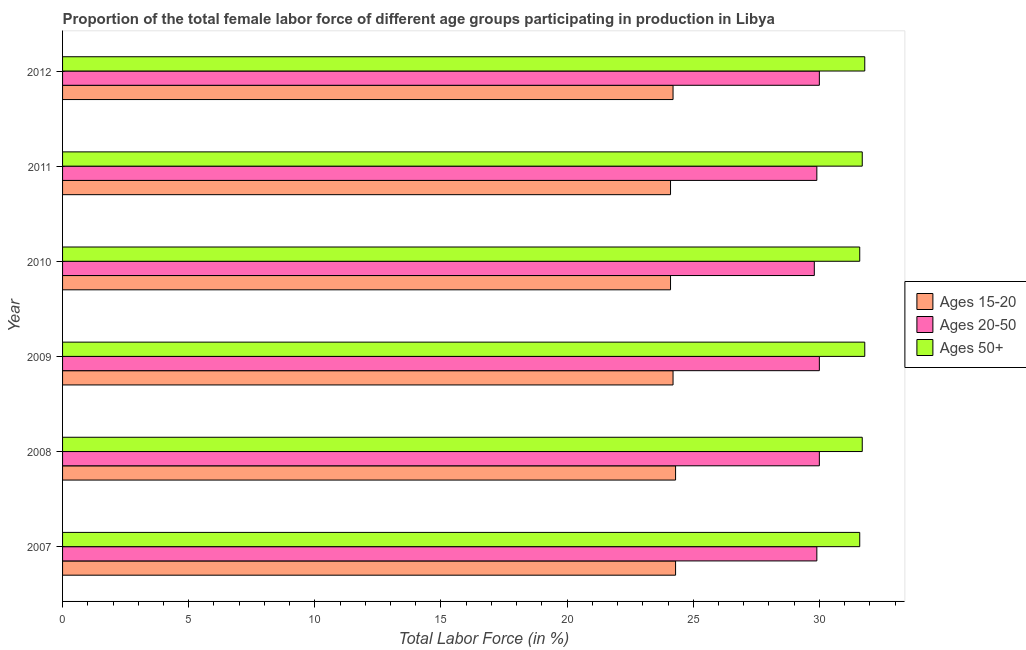How many different coloured bars are there?
Your answer should be very brief. 3. Are the number of bars on each tick of the Y-axis equal?
Provide a succinct answer. Yes. What is the label of the 2nd group of bars from the top?
Make the answer very short. 2011. What is the percentage of female labor force above age 50 in 2009?
Your answer should be compact. 31.8. Across all years, what is the maximum percentage of female labor force within the age group 20-50?
Offer a terse response. 30. Across all years, what is the minimum percentage of female labor force within the age group 15-20?
Give a very brief answer. 24.1. In which year was the percentage of female labor force within the age group 15-20 minimum?
Make the answer very short. 2010. What is the total percentage of female labor force above age 50 in the graph?
Ensure brevity in your answer.  190.2. What is the difference between the percentage of female labor force above age 50 in 2007 and that in 2011?
Your response must be concise. -0.1. What is the average percentage of female labor force within the age group 15-20 per year?
Provide a succinct answer. 24.2. What is the ratio of the percentage of female labor force within the age group 15-20 in 2007 to that in 2012?
Offer a very short reply. 1. Is the difference between the percentage of female labor force within the age group 20-50 in 2009 and 2011 greater than the difference between the percentage of female labor force above age 50 in 2009 and 2011?
Provide a short and direct response. Yes. What is the difference between the highest and the second highest percentage of female labor force above age 50?
Make the answer very short. 0. What is the difference between the highest and the lowest percentage of female labor force within the age group 15-20?
Offer a very short reply. 0.2. In how many years, is the percentage of female labor force above age 50 greater than the average percentage of female labor force above age 50 taken over all years?
Offer a terse response. 4. What does the 3rd bar from the top in 2012 represents?
Your answer should be compact. Ages 15-20. What does the 2nd bar from the bottom in 2012 represents?
Your answer should be compact. Ages 20-50. Is it the case that in every year, the sum of the percentage of female labor force within the age group 15-20 and percentage of female labor force within the age group 20-50 is greater than the percentage of female labor force above age 50?
Your response must be concise. Yes. How many bars are there?
Provide a short and direct response. 18. How many years are there in the graph?
Give a very brief answer. 6. What is the difference between two consecutive major ticks on the X-axis?
Ensure brevity in your answer.  5. Does the graph contain grids?
Your answer should be very brief. No. Where does the legend appear in the graph?
Your answer should be compact. Center right. How many legend labels are there?
Your response must be concise. 3. How are the legend labels stacked?
Ensure brevity in your answer.  Vertical. What is the title of the graph?
Provide a succinct answer. Proportion of the total female labor force of different age groups participating in production in Libya. Does "Taxes" appear as one of the legend labels in the graph?
Offer a terse response. No. What is the Total Labor Force (in %) in Ages 15-20 in 2007?
Offer a very short reply. 24.3. What is the Total Labor Force (in %) of Ages 20-50 in 2007?
Your answer should be very brief. 29.9. What is the Total Labor Force (in %) of Ages 50+ in 2007?
Offer a terse response. 31.6. What is the Total Labor Force (in %) in Ages 15-20 in 2008?
Offer a terse response. 24.3. What is the Total Labor Force (in %) in Ages 20-50 in 2008?
Provide a short and direct response. 30. What is the Total Labor Force (in %) in Ages 50+ in 2008?
Ensure brevity in your answer.  31.7. What is the Total Labor Force (in %) of Ages 15-20 in 2009?
Offer a very short reply. 24.2. What is the Total Labor Force (in %) in Ages 20-50 in 2009?
Provide a short and direct response. 30. What is the Total Labor Force (in %) in Ages 50+ in 2009?
Offer a very short reply. 31.8. What is the Total Labor Force (in %) of Ages 15-20 in 2010?
Your response must be concise. 24.1. What is the Total Labor Force (in %) of Ages 20-50 in 2010?
Make the answer very short. 29.8. What is the Total Labor Force (in %) of Ages 50+ in 2010?
Ensure brevity in your answer.  31.6. What is the Total Labor Force (in %) of Ages 15-20 in 2011?
Make the answer very short. 24.1. What is the Total Labor Force (in %) of Ages 20-50 in 2011?
Provide a succinct answer. 29.9. What is the Total Labor Force (in %) in Ages 50+ in 2011?
Make the answer very short. 31.7. What is the Total Labor Force (in %) in Ages 15-20 in 2012?
Provide a short and direct response. 24.2. What is the Total Labor Force (in %) of Ages 50+ in 2012?
Provide a short and direct response. 31.8. Across all years, what is the maximum Total Labor Force (in %) of Ages 15-20?
Keep it short and to the point. 24.3. Across all years, what is the maximum Total Labor Force (in %) of Ages 50+?
Give a very brief answer. 31.8. Across all years, what is the minimum Total Labor Force (in %) in Ages 15-20?
Provide a short and direct response. 24.1. Across all years, what is the minimum Total Labor Force (in %) in Ages 20-50?
Give a very brief answer. 29.8. Across all years, what is the minimum Total Labor Force (in %) in Ages 50+?
Your answer should be compact. 31.6. What is the total Total Labor Force (in %) in Ages 15-20 in the graph?
Your response must be concise. 145.2. What is the total Total Labor Force (in %) of Ages 20-50 in the graph?
Your response must be concise. 179.6. What is the total Total Labor Force (in %) of Ages 50+ in the graph?
Your answer should be very brief. 190.2. What is the difference between the Total Labor Force (in %) of Ages 15-20 in 2007 and that in 2008?
Ensure brevity in your answer.  0. What is the difference between the Total Labor Force (in %) in Ages 50+ in 2007 and that in 2008?
Provide a short and direct response. -0.1. What is the difference between the Total Labor Force (in %) in Ages 50+ in 2007 and that in 2009?
Your response must be concise. -0.2. What is the difference between the Total Labor Force (in %) in Ages 50+ in 2007 and that in 2010?
Provide a succinct answer. 0. What is the difference between the Total Labor Force (in %) of Ages 20-50 in 2007 and that in 2011?
Your response must be concise. 0. What is the difference between the Total Labor Force (in %) of Ages 50+ in 2007 and that in 2011?
Your response must be concise. -0.1. What is the difference between the Total Labor Force (in %) of Ages 15-20 in 2007 and that in 2012?
Ensure brevity in your answer.  0.1. What is the difference between the Total Labor Force (in %) in Ages 20-50 in 2007 and that in 2012?
Offer a terse response. -0.1. What is the difference between the Total Labor Force (in %) of Ages 50+ in 2007 and that in 2012?
Provide a succinct answer. -0.2. What is the difference between the Total Labor Force (in %) of Ages 20-50 in 2008 and that in 2009?
Make the answer very short. 0. What is the difference between the Total Labor Force (in %) in Ages 50+ in 2008 and that in 2009?
Your answer should be very brief. -0.1. What is the difference between the Total Labor Force (in %) in Ages 15-20 in 2008 and that in 2010?
Ensure brevity in your answer.  0.2. What is the difference between the Total Labor Force (in %) in Ages 15-20 in 2008 and that in 2011?
Provide a short and direct response. 0.2. What is the difference between the Total Labor Force (in %) in Ages 20-50 in 2008 and that in 2012?
Offer a very short reply. 0. What is the difference between the Total Labor Force (in %) in Ages 50+ in 2008 and that in 2012?
Provide a short and direct response. -0.1. What is the difference between the Total Labor Force (in %) of Ages 15-20 in 2009 and that in 2010?
Make the answer very short. 0.1. What is the difference between the Total Labor Force (in %) of Ages 15-20 in 2009 and that in 2011?
Your answer should be compact. 0.1. What is the difference between the Total Labor Force (in %) in Ages 20-50 in 2009 and that in 2011?
Keep it short and to the point. 0.1. What is the difference between the Total Labor Force (in %) of Ages 50+ in 2009 and that in 2011?
Your answer should be compact. 0.1. What is the difference between the Total Labor Force (in %) in Ages 15-20 in 2009 and that in 2012?
Your response must be concise. 0. What is the difference between the Total Labor Force (in %) in Ages 15-20 in 2010 and that in 2012?
Your response must be concise. -0.1. What is the difference between the Total Labor Force (in %) of Ages 20-50 in 2010 and that in 2012?
Offer a very short reply. -0.2. What is the difference between the Total Labor Force (in %) in Ages 20-50 in 2011 and that in 2012?
Your response must be concise. -0.1. What is the difference between the Total Labor Force (in %) in Ages 50+ in 2011 and that in 2012?
Make the answer very short. -0.1. What is the difference between the Total Labor Force (in %) in Ages 15-20 in 2007 and the Total Labor Force (in %) in Ages 20-50 in 2009?
Offer a very short reply. -5.7. What is the difference between the Total Labor Force (in %) of Ages 15-20 in 2007 and the Total Labor Force (in %) of Ages 50+ in 2009?
Offer a very short reply. -7.5. What is the difference between the Total Labor Force (in %) of Ages 20-50 in 2007 and the Total Labor Force (in %) of Ages 50+ in 2009?
Your answer should be compact. -1.9. What is the difference between the Total Labor Force (in %) of Ages 15-20 in 2007 and the Total Labor Force (in %) of Ages 50+ in 2010?
Your answer should be very brief. -7.3. What is the difference between the Total Labor Force (in %) in Ages 20-50 in 2007 and the Total Labor Force (in %) in Ages 50+ in 2010?
Ensure brevity in your answer.  -1.7. What is the difference between the Total Labor Force (in %) in Ages 15-20 in 2007 and the Total Labor Force (in %) in Ages 20-50 in 2011?
Keep it short and to the point. -5.6. What is the difference between the Total Labor Force (in %) in Ages 20-50 in 2007 and the Total Labor Force (in %) in Ages 50+ in 2011?
Offer a very short reply. -1.8. What is the difference between the Total Labor Force (in %) in Ages 15-20 in 2007 and the Total Labor Force (in %) in Ages 20-50 in 2012?
Offer a very short reply. -5.7. What is the difference between the Total Labor Force (in %) of Ages 15-20 in 2007 and the Total Labor Force (in %) of Ages 50+ in 2012?
Your answer should be very brief. -7.5. What is the difference between the Total Labor Force (in %) in Ages 20-50 in 2007 and the Total Labor Force (in %) in Ages 50+ in 2012?
Keep it short and to the point. -1.9. What is the difference between the Total Labor Force (in %) in Ages 15-20 in 2008 and the Total Labor Force (in %) in Ages 20-50 in 2010?
Provide a short and direct response. -5.5. What is the difference between the Total Labor Force (in %) of Ages 15-20 in 2008 and the Total Labor Force (in %) of Ages 50+ in 2010?
Offer a terse response. -7.3. What is the difference between the Total Labor Force (in %) of Ages 20-50 in 2008 and the Total Labor Force (in %) of Ages 50+ in 2010?
Your answer should be very brief. -1.6. What is the difference between the Total Labor Force (in %) of Ages 15-20 in 2008 and the Total Labor Force (in %) of Ages 20-50 in 2011?
Your answer should be very brief. -5.6. What is the difference between the Total Labor Force (in %) in Ages 15-20 in 2008 and the Total Labor Force (in %) in Ages 50+ in 2011?
Provide a short and direct response. -7.4. What is the difference between the Total Labor Force (in %) of Ages 20-50 in 2008 and the Total Labor Force (in %) of Ages 50+ in 2012?
Ensure brevity in your answer.  -1.8. What is the difference between the Total Labor Force (in %) in Ages 15-20 in 2009 and the Total Labor Force (in %) in Ages 20-50 in 2010?
Offer a very short reply. -5.6. What is the difference between the Total Labor Force (in %) of Ages 15-20 in 2009 and the Total Labor Force (in %) of Ages 50+ in 2010?
Give a very brief answer. -7.4. What is the difference between the Total Labor Force (in %) of Ages 20-50 in 2009 and the Total Labor Force (in %) of Ages 50+ in 2010?
Offer a terse response. -1.6. What is the difference between the Total Labor Force (in %) of Ages 15-20 in 2009 and the Total Labor Force (in %) of Ages 20-50 in 2011?
Your answer should be compact. -5.7. What is the difference between the Total Labor Force (in %) in Ages 15-20 in 2009 and the Total Labor Force (in %) in Ages 50+ in 2011?
Your response must be concise. -7.5. What is the difference between the Total Labor Force (in %) of Ages 15-20 in 2009 and the Total Labor Force (in %) of Ages 50+ in 2012?
Your response must be concise. -7.6. What is the difference between the Total Labor Force (in %) in Ages 15-20 in 2010 and the Total Labor Force (in %) in Ages 50+ in 2011?
Provide a short and direct response. -7.6. What is the difference between the Total Labor Force (in %) in Ages 20-50 in 2010 and the Total Labor Force (in %) in Ages 50+ in 2011?
Give a very brief answer. -1.9. What is the difference between the Total Labor Force (in %) in Ages 20-50 in 2010 and the Total Labor Force (in %) in Ages 50+ in 2012?
Your response must be concise. -2. What is the difference between the Total Labor Force (in %) in Ages 15-20 in 2011 and the Total Labor Force (in %) in Ages 50+ in 2012?
Your answer should be compact. -7.7. What is the difference between the Total Labor Force (in %) of Ages 20-50 in 2011 and the Total Labor Force (in %) of Ages 50+ in 2012?
Ensure brevity in your answer.  -1.9. What is the average Total Labor Force (in %) in Ages 15-20 per year?
Offer a terse response. 24.2. What is the average Total Labor Force (in %) of Ages 20-50 per year?
Your answer should be very brief. 29.93. What is the average Total Labor Force (in %) of Ages 50+ per year?
Ensure brevity in your answer.  31.7. In the year 2007, what is the difference between the Total Labor Force (in %) of Ages 15-20 and Total Labor Force (in %) of Ages 20-50?
Make the answer very short. -5.6. In the year 2007, what is the difference between the Total Labor Force (in %) of Ages 15-20 and Total Labor Force (in %) of Ages 50+?
Make the answer very short. -7.3. In the year 2007, what is the difference between the Total Labor Force (in %) in Ages 20-50 and Total Labor Force (in %) in Ages 50+?
Offer a very short reply. -1.7. In the year 2008, what is the difference between the Total Labor Force (in %) of Ages 15-20 and Total Labor Force (in %) of Ages 20-50?
Provide a short and direct response. -5.7. In the year 2009, what is the difference between the Total Labor Force (in %) of Ages 15-20 and Total Labor Force (in %) of Ages 20-50?
Provide a short and direct response. -5.8. In the year 2009, what is the difference between the Total Labor Force (in %) in Ages 15-20 and Total Labor Force (in %) in Ages 50+?
Give a very brief answer. -7.6. In the year 2010, what is the difference between the Total Labor Force (in %) in Ages 15-20 and Total Labor Force (in %) in Ages 50+?
Make the answer very short. -7.5. In the year 2010, what is the difference between the Total Labor Force (in %) in Ages 20-50 and Total Labor Force (in %) in Ages 50+?
Your response must be concise. -1.8. In the year 2011, what is the difference between the Total Labor Force (in %) in Ages 15-20 and Total Labor Force (in %) in Ages 20-50?
Your answer should be very brief. -5.8. In the year 2012, what is the difference between the Total Labor Force (in %) of Ages 15-20 and Total Labor Force (in %) of Ages 20-50?
Make the answer very short. -5.8. In the year 2012, what is the difference between the Total Labor Force (in %) of Ages 20-50 and Total Labor Force (in %) of Ages 50+?
Offer a terse response. -1.8. What is the ratio of the Total Labor Force (in %) of Ages 20-50 in 2007 to that in 2008?
Your answer should be very brief. 1. What is the ratio of the Total Labor Force (in %) of Ages 50+ in 2007 to that in 2008?
Provide a short and direct response. 1. What is the ratio of the Total Labor Force (in %) in Ages 15-20 in 2007 to that in 2009?
Ensure brevity in your answer.  1. What is the ratio of the Total Labor Force (in %) of Ages 20-50 in 2007 to that in 2009?
Your response must be concise. 1. What is the ratio of the Total Labor Force (in %) of Ages 50+ in 2007 to that in 2009?
Ensure brevity in your answer.  0.99. What is the ratio of the Total Labor Force (in %) in Ages 15-20 in 2007 to that in 2010?
Your response must be concise. 1.01. What is the ratio of the Total Labor Force (in %) in Ages 15-20 in 2007 to that in 2011?
Offer a very short reply. 1.01. What is the ratio of the Total Labor Force (in %) in Ages 20-50 in 2007 to that in 2011?
Provide a succinct answer. 1. What is the ratio of the Total Labor Force (in %) of Ages 20-50 in 2007 to that in 2012?
Offer a very short reply. 1. What is the ratio of the Total Labor Force (in %) of Ages 50+ in 2007 to that in 2012?
Make the answer very short. 0.99. What is the ratio of the Total Labor Force (in %) of Ages 15-20 in 2008 to that in 2009?
Provide a succinct answer. 1. What is the ratio of the Total Labor Force (in %) in Ages 50+ in 2008 to that in 2009?
Your answer should be compact. 1. What is the ratio of the Total Labor Force (in %) of Ages 15-20 in 2008 to that in 2010?
Your response must be concise. 1.01. What is the ratio of the Total Labor Force (in %) in Ages 15-20 in 2008 to that in 2011?
Give a very brief answer. 1.01. What is the ratio of the Total Labor Force (in %) of Ages 50+ in 2008 to that in 2011?
Provide a succinct answer. 1. What is the ratio of the Total Labor Force (in %) of Ages 15-20 in 2008 to that in 2012?
Give a very brief answer. 1. What is the ratio of the Total Labor Force (in %) in Ages 20-50 in 2008 to that in 2012?
Ensure brevity in your answer.  1. What is the ratio of the Total Labor Force (in %) in Ages 20-50 in 2009 to that in 2010?
Offer a terse response. 1.01. What is the ratio of the Total Labor Force (in %) in Ages 50+ in 2009 to that in 2011?
Provide a succinct answer. 1. What is the ratio of the Total Labor Force (in %) in Ages 15-20 in 2009 to that in 2012?
Offer a very short reply. 1. What is the ratio of the Total Labor Force (in %) of Ages 50+ in 2009 to that in 2012?
Keep it short and to the point. 1. What is the ratio of the Total Labor Force (in %) of Ages 15-20 in 2010 to that in 2011?
Keep it short and to the point. 1. What is the ratio of the Total Labor Force (in %) in Ages 15-20 in 2010 to that in 2012?
Provide a succinct answer. 1. What is the ratio of the Total Labor Force (in %) of Ages 50+ in 2010 to that in 2012?
Your response must be concise. 0.99. What is the ratio of the Total Labor Force (in %) in Ages 15-20 in 2011 to that in 2012?
Your response must be concise. 1. What is the difference between the highest and the lowest Total Labor Force (in %) of Ages 15-20?
Ensure brevity in your answer.  0.2. What is the difference between the highest and the lowest Total Labor Force (in %) in Ages 20-50?
Ensure brevity in your answer.  0.2. 